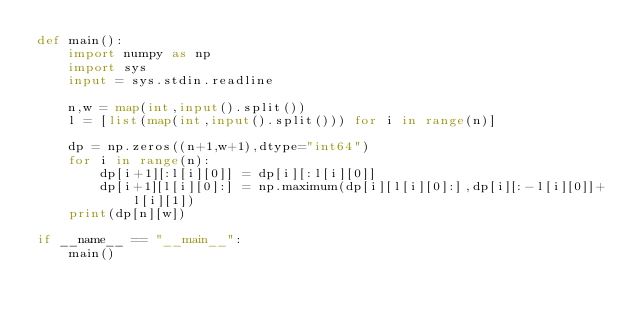<code> <loc_0><loc_0><loc_500><loc_500><_Python_>def main():
    import numpy as np
    import sys
    input = sys.stdin.readline

    n,w = map(int,input().split())
    l = [list(map(int,input().split())) for i in range(n)]

    dp = np.zeros((n+1,w+1),dtype="int64")
    for i in range(n):
        dp[i+1][:l[i][0]] = dp[i][:l[i][0]]
        dp[i+1][l[i][0]:] = np.maximum(dp[i][l[i][0]:],dp[i][:-l[i][0]]+l[i][1])
    print(dp[n][w])

if __name__ == "__main__":
    main()</code> 